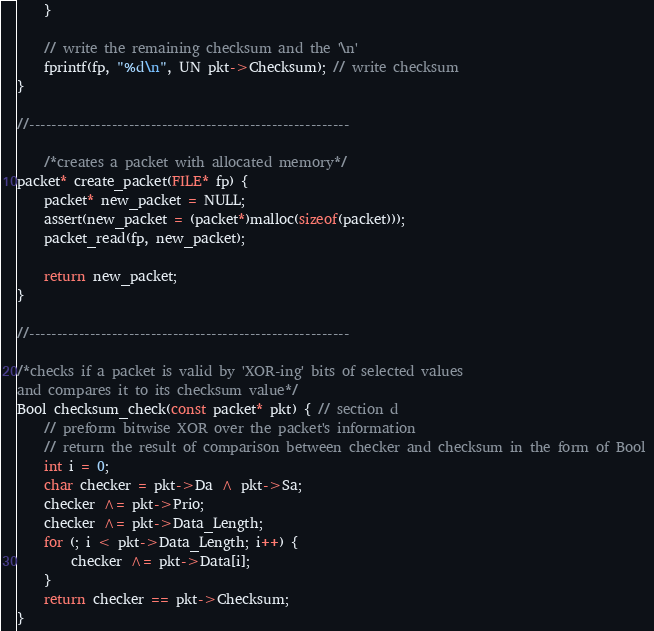Convert code to text. <code><loc_0><loc_0><loc_500><loc_500><_C_>	}

	// write the remaining checksum and the '\n' 
	fprintf(fp, "%d\n", UN pkt->Checksum); // write checksum
}

//----------------------------------------------------------

	/*creates a packet with allocated memory*/
packet* create_packet(FILE* fp) {
	packet* new_packet = NULL;
	assert(new_packet = (packet*)malloc(sizeof(packet)));
	packet_read(fp, new_packet);

	return new_packet;
}

//----------------------------------------------------------

/*checks if a packet is valid by 'XOR-ing' bits of selected values
and compares it to its checksum value*/
Bool checksum_check(const packet* pkt) { // section d
	// preform bitwise XOR over the packet's information
	// return the result of comparison between checker and checksum in the form of Bool 
	int i = 0;
	char checker = pkt->Da ^ pkt->Sa;
	checker ^= pkt->Prio;
	checker ^= pkt->Data_Length;
	for (; i < pkt->Data_Length; i++) {
		checker ^= pkt->Data[i];
	}
	return checker == pkt->Checksum;
}
</code> 